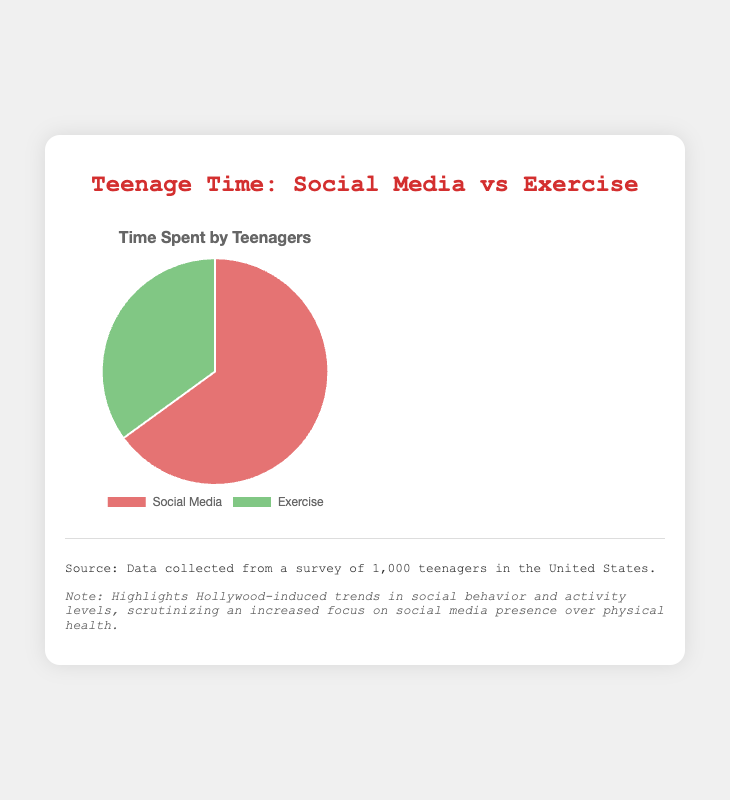What percentage of time do teenagers spend on social media compared to exercise? According to the pie chart, teenagers spend 65% of their time on social media and 35% on exercise.
Answer: 65% By how much is the time spent on social media greater than the time spent on exercise? To find the difference, subtract the percentage of time spent on exercise (35%) from the percentage of time spent on social media (65%): 65% - 35% = 30%.
Answer: 30% What is the combined percentage of time teenagers spend on social media and exercise? Adding the percentage of time spent on social media (65%) and the time spent on exercise (35%) gives: 65% + 35% = 100%.
Answer: 100% If you divide the percentage of time spent on social media by the percentage of time spent on exercise, what is the ratio? Dividing the percentage of time spent on social media (65%) by the time spent on exercise (35%): 65% / 35% ≈ 1.86.
Answer: 1.86 Which category has the larger proportion of the pie chart? By visual inspection, the "Social Media" section covers a larger area of the pie chart compared to the "Exercise" section.
Answer: Social Media What would be the remaining percentage if we doubled the time spent on exercise? Doubling the time spent on exercise: 35% * 2 = 70%. The pie chart sum must be 100%, so the remaining percentage for social media would be 100% - 70% = 30%.
Answer: 30% What colors represent the categories in the pie chart? The category "Social Media" is represented in red shades, while "Exercise" is represented in green shades.
Answer: Red and Green How much more time do teenagers spend on social media than exercise? Subtract the percentage of time spent on exercise (35%) from the percentage of time spent on social media (65%): 65% - 35% = 30%.
Answer: 30% What can we infer about Hollywood’s influence on teenagers’ activity levels from the pie chart? The annotations indicate that there is a Hollywood-induced trend towards spending more time on social media (65%) compared to physical health activities like exercise (35%). This could imply that the influence of celebrities and online personalities is causing teenagers to prioritize social presence over physical activity.
Answer: More time on social media due to Hollywood influence 